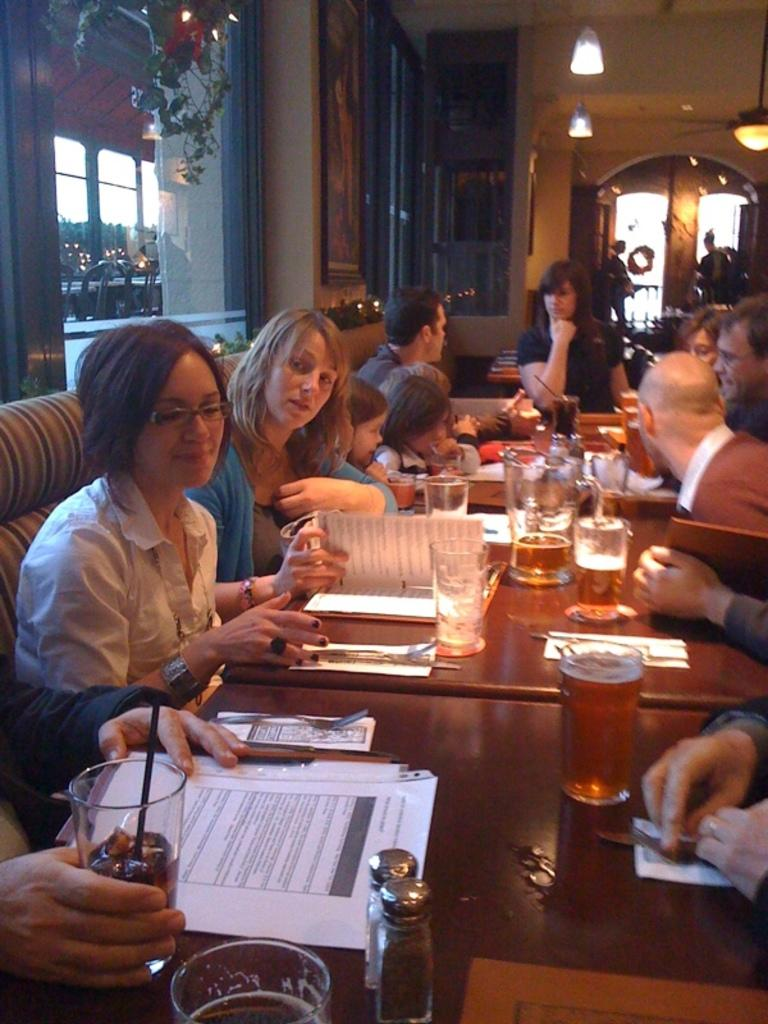What are the people in the image doing? The people in the image are sitting. What can be seen on the table in the image? There are papers and a glass on the table in the image. What other objects are visible in the image? There are objects on the table in the image. What can be seen in the background of the image? There is a glass window, lights, and frames attached to the wall in the background of the image. What flavor of ice cream is being burned in the image? There is no ice cream present in the image, and therefore no flavor can be determined or burned. 